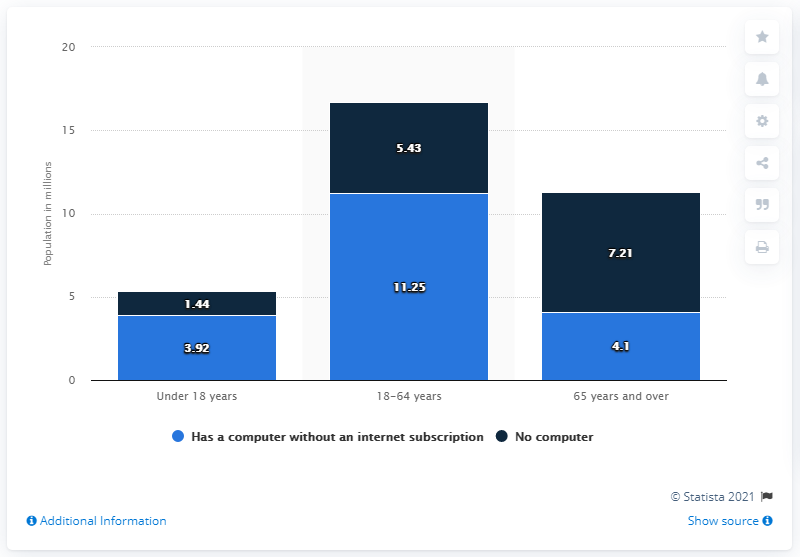Indicate a few pertinent items in this graphic. During the survey period, 4.1% of people aged 65 or older reported having a computer but no internet subscription. 